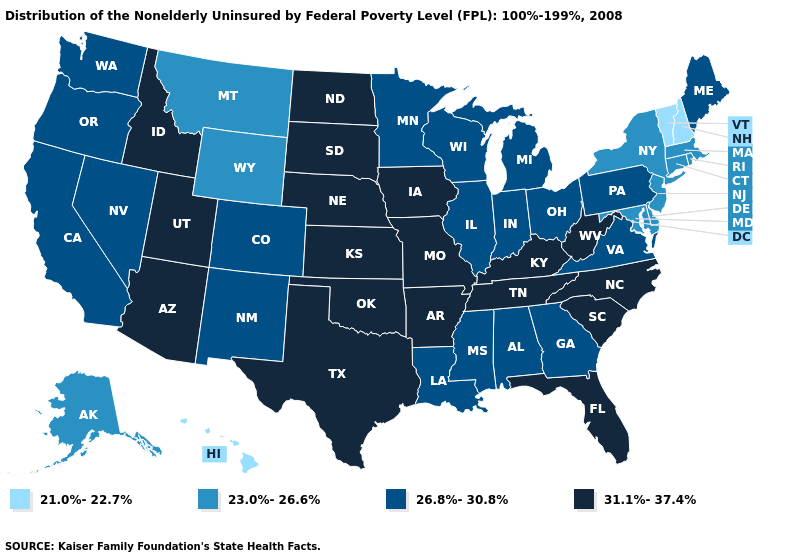What is the value of Indiana?
Answer briefly. 26.8%-30.8%. Name the states that have a value in the range 21.0%-22.7%?
Concise answer only. Hawaii, New Hampshire, Vermont. Among the states that border California , does Oregon have the lowest value?
Answer briefly. Yes. What is the value of Louisiana?
Short answer required. 26.8%-30.8%. What is the value of Illinois?
Keep it brief. 26.8%-30.8%. What is the value of West Virginia?
Concise answer only. 31.1%-37.4%. Does the map have missing data?
Give a very brief answer. No. Does Michigan have a higher value than South Carolina?
Give a very brief answer. No. Does the map have missing data?
Answer briefly. No. What is the highest value in the West ?
Short answer required. 31.1%-37.4%. What is the lowest value in the USA?
Answer briefly. 21.0%-22.7%. Among the states that border Illinois , does Indiana have the lowest value?
Concise answer only. Yes. Among the states that border Kansas , which have the highest value?
Quick response, please. Missouri, Nebraska, Oklahoma. What is the value of North Carolina?
Give a very brief answer. 31.1%-37.4%. Does Kentucky have the highest value in the South?
Give a very brief answer. Yes. 